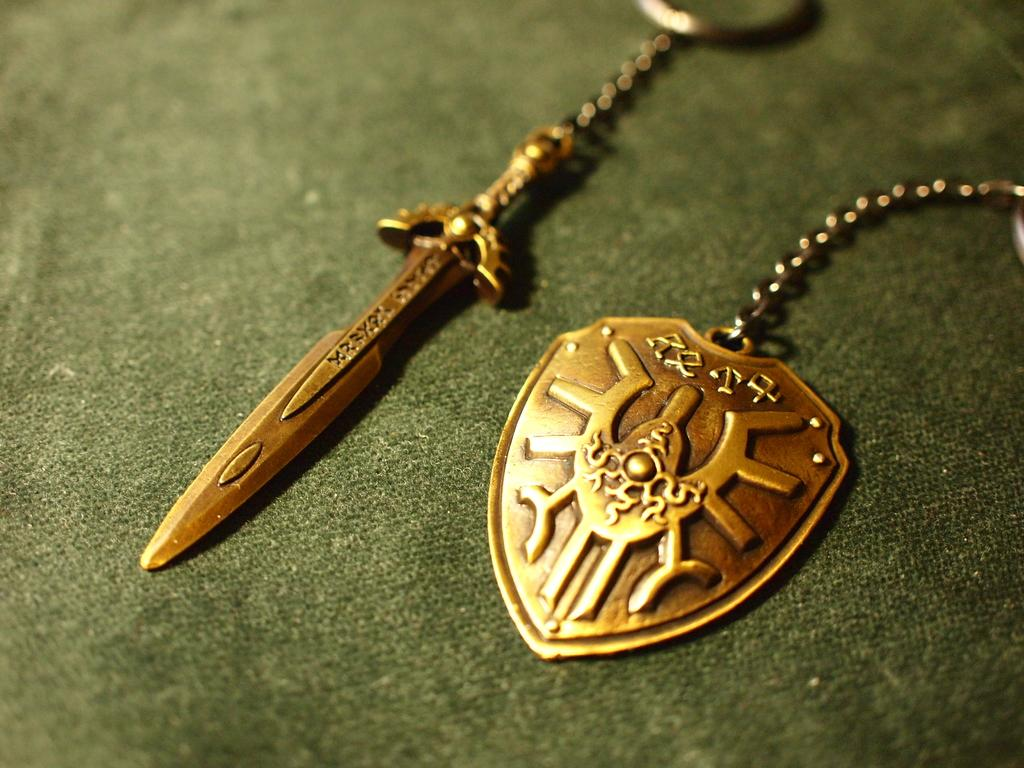What type of object is featured on the keychain in the image? There is a sword keychain in the image. Are there any other keychains visible in the image? Yes, there is another keychain in the image. What can be seen on the other keychain? The other keychain has a logo on it. How does the fog affect the visibility of the ship in the image? There is no ship or fog present in the image; it only features keychains. 